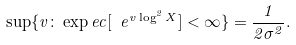Convert formula to latex. <formula><loc_0><loc_0><loc_500><loc_500>\sup \{ v \colon \exp e c [ \ e ^ { v \log ^ { 2 } X } ] < \infty \} = \frac { 1 } { 2 \sigma ^ { 2 } } .</formula> 